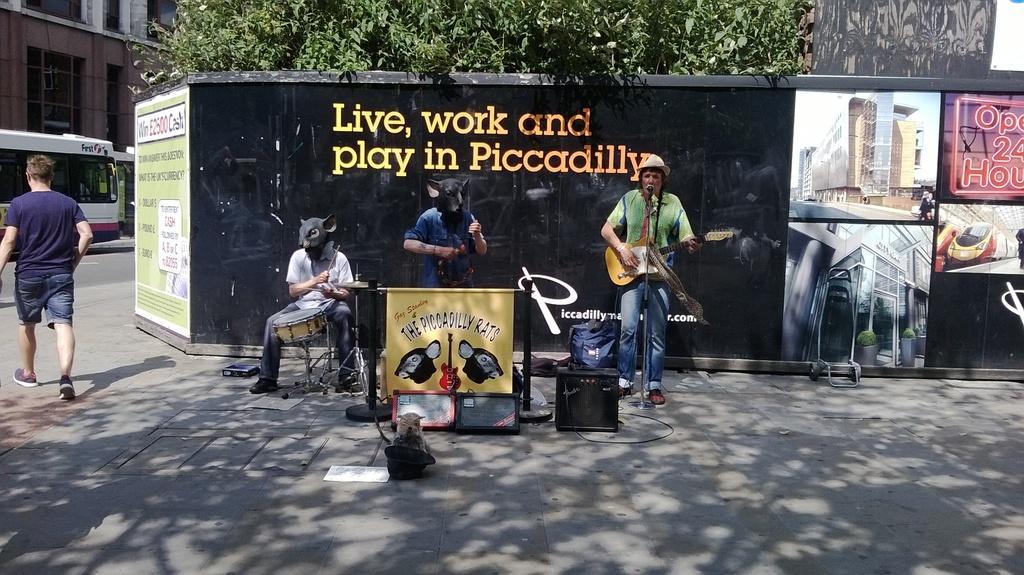Could you give a brief overview of what you see in this image? In this image there are three persons playing musical instruments. These two persons are wearing mask, person towards the right, he is wearing a hat and holding a guitar. Towards the left corner there is a man walking. In the background there are trees, building, 
 train and a shed. 